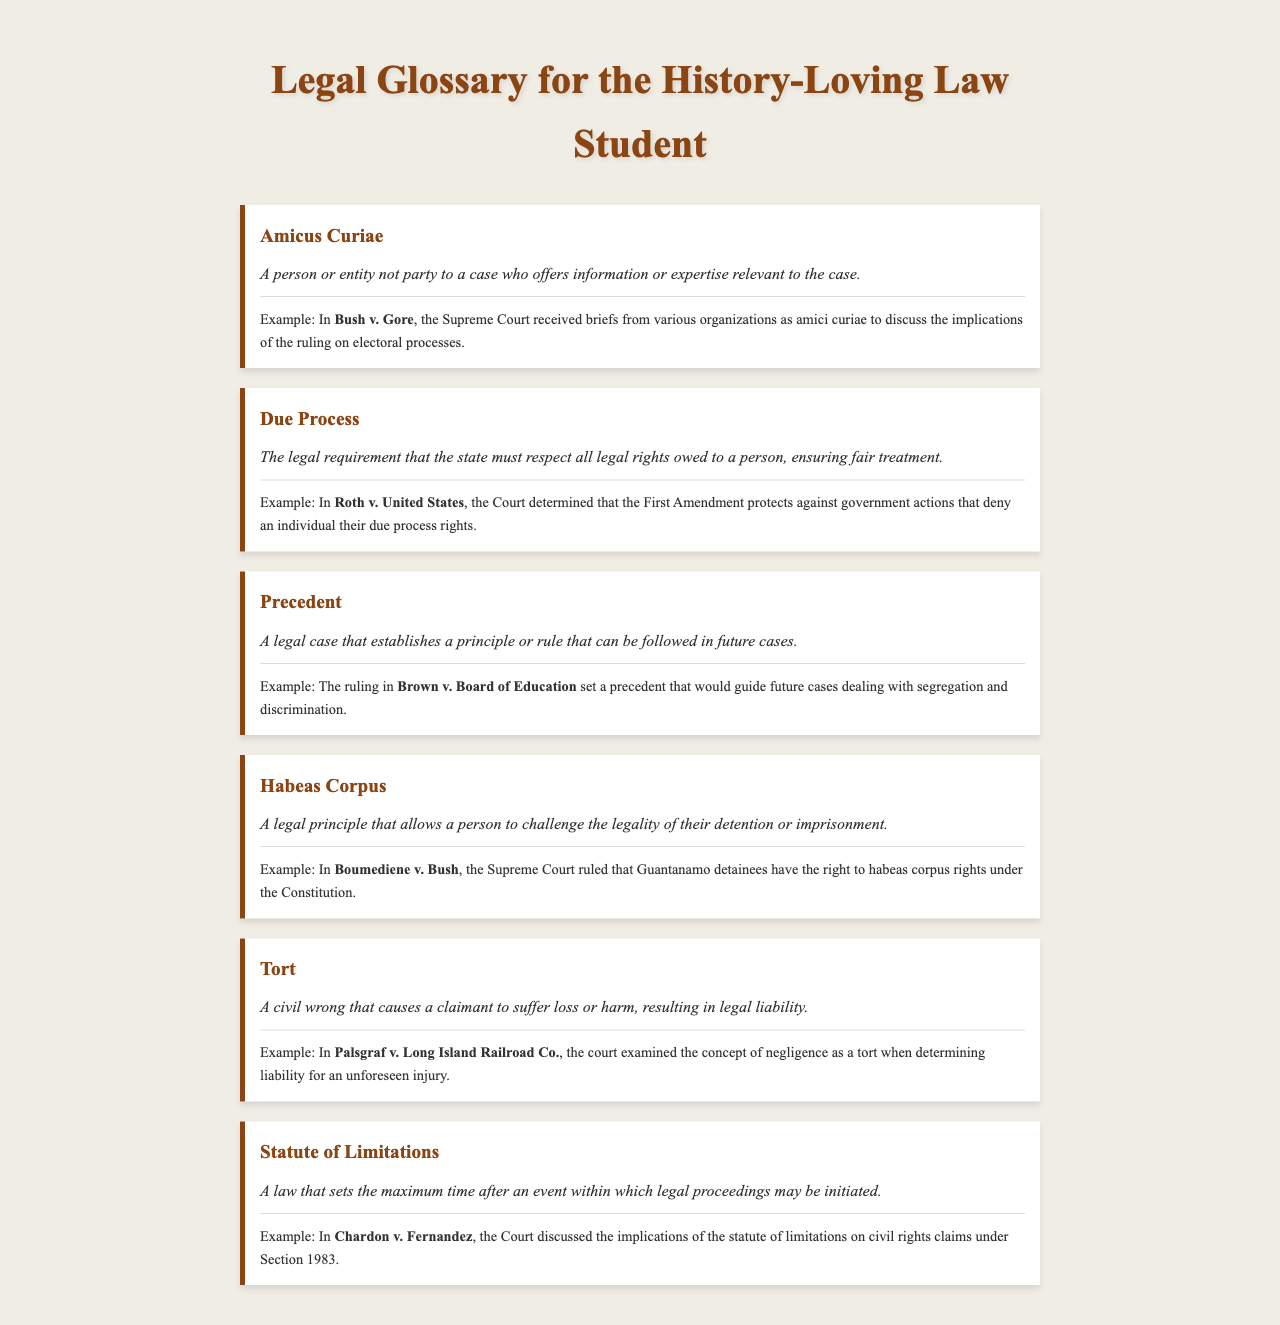What is Amicus Curiae? Amicus Curiae is defined as a person or entity not party to a case who offers information or expertise relevant to the case.
Answer: A person or entity not party to a case What landmark case involved Amicus Curiae? The example given for Amicus Curiae is in the case of Bush v. Gore, where briefs were received from various organizations as amici curiae.
Answer: Bush v. Gore What does Due Process ensure? Due Process ensures the legal requirement that the state must respect all legal rights owed to a person, ensuring fair treatment.
Answer: Fair treatment What case discussed Due Process rights? The case that determined due process rights in this context is Roth v. United States.
Answer: Roth v. United States What principle does Precedent establish? Precedent establishes a principle or rule that can be followed in future cases.
Answer: A principle or rule In which case was the precedent about segregation set? The precedent regarding segregation was set in Brown v. Board of Education.
Answer: Brown v. Board of Education What legal principle does Habeas Corpus relate to? Habeas Corpus relates to challenging the legality of their detention or imprisonment.
Answer: Legality of detention Which case affirmed Habeas Corpus rights for Guantanamo detainees? The case that affirmed habeas corpus rights for Guantanamo detainees is Boumediene v. Bush.
Answer: Boumediene v. Bush What type of wrong does Tort refer to? Tort refers to a civil wrong that causes a claimant to suffer loss or harm.
Answer: Civil wrong What was the key legal concept examined in Palsgraf v. Long Island Railroad Co.? The key concept examined was negligence as a tort when determining liability for an unforeseen injury.
Answer: Negligence as a tort 